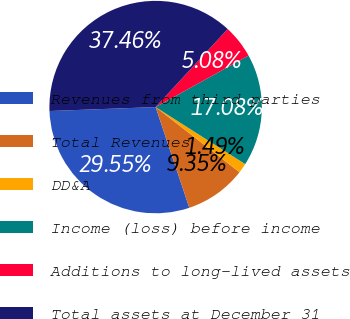Convert chart. <chart><loc_0><loc_0><loc_500><loc_500><pie_chart><fcel>Revenues from third parties<fcel>Total Revenues<fcel>DD&A<fcel>Income (loss) before income<fcel>Additions to long-lived assets<fcel>Total assets at December 31<nl><fcel>29.55%<fcel>9.35%<fcel>1.49%<fcel>17.08%<fcel>5.08%<fcel>37.46%<nl></chart> 